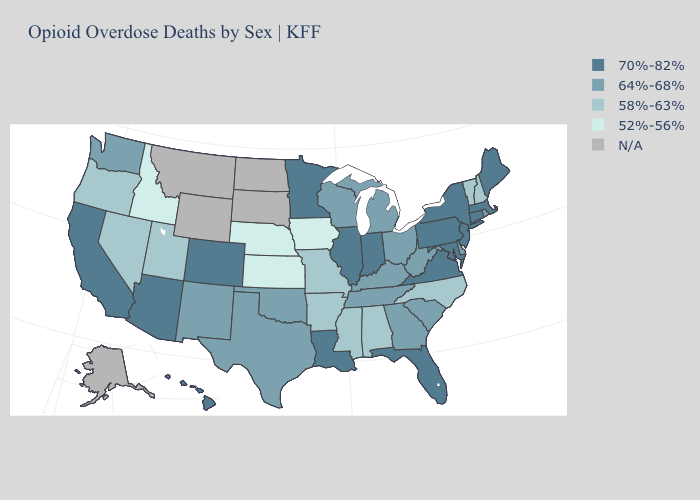What is the lowest value in the USA?
Give a very brief answer. 52%-56%. Name the states that have a value in the range 64%-68%?
Concise answer only. Delaware, Georgia, Kentucky, Michigan, New Mexico, Ohio, Oklahoma, Rhode Island, South Carolina, Tennessee, Texas, Washington, West Virginia, Wisconsin. Name the states that have a value in the range 64%-68%?
Answer briefly. Delaware, Georgia, Kentucky, Michigan, New Mexico, Ohio, Oklahoma, Rhode Island, South Carolina, Tennessee, Texas, Washington, West Virginia, Wisconsin. What is the value of Delaware?
Short answer required. 64%-68%. Among the states that border Nebraska , does Iowa have the lowest value?
Give a very brief answer. Yes. What is the value of Maryland?
Quick response, please. 70%-82%. What is the value of Iowa?
Concise answer only. 52%-56%. Does Florida have the highest value in the South?
Quick response, please. Yes. What is the value of Virginia?
Answer briefly. 70%-82%. Name the states that have a value in the range 52%-56%?
Be succinct. Idaho, Iowa, Kansas, Nebraska. Name the states that have a value in the range 52%-56%?
Give a very brief answer. Idaho, Iowa, Kansas, Nebraska. Name the states that have a value in the range 52%-56%?
Write a very short answer. Idaho, Iowa, Kansas, Nebraska. Name the states that have a value in the range 58%-63%?
Short answer required. Alabama, Arkansas, Mississippi, Missouri, Nevada, New Hampshire, North Carolina, Oregon, Utah, Vermont. Which states hav the highest value in the West?
Quick response, please. Arizona, California, Colorado, Hawaii. Name the states that have a value in the range N/A?
Concise answer only. Alaska, Montana, North Dakota, South Dakota, Wyoming. 